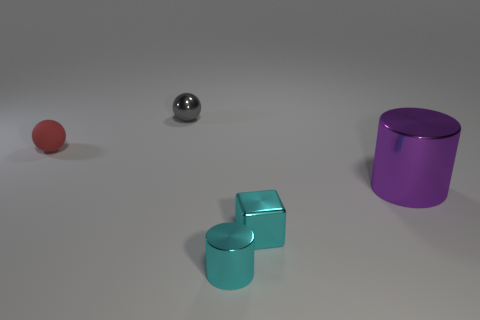What lighting conditions are suggested by the shadows in the image? The shadows cast by the objects suggest a diffuse light source coming from above and to the left. The shadows are soft-edged and elongated, indicating a single light source that is not extremely close to the objects. The overall ambience is soft and consistent with indoor lighting conditions. 